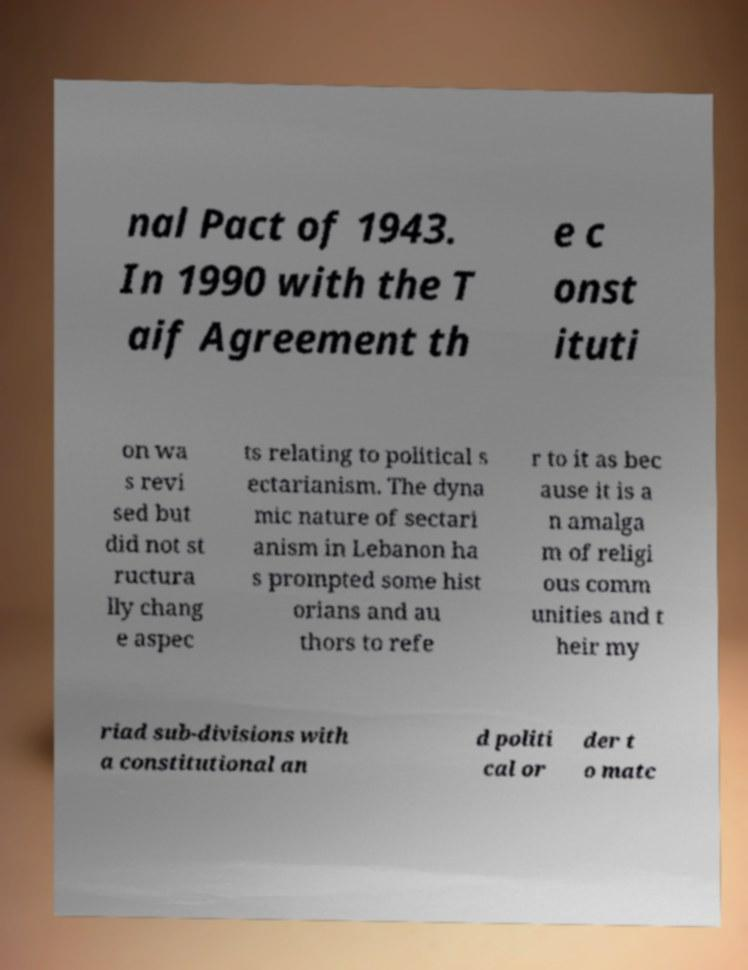Please read and relay the text visible in this image. What does it say? nal Pact of 1943. In 1990 with the T aif Agreement th e c onst ituti on wa s revi sed but did not st ructura lly chang e aspec ts relating to political s ectarianism. The dyna mic nature of sectari anism in Lebanon ha s prompted some hist orians and au thors to refe r to it as bec ause it is a n amalga m of religi ous comm unities and t heir my riad sub-divisions with a constitutional an d politi cal or der t o matc 